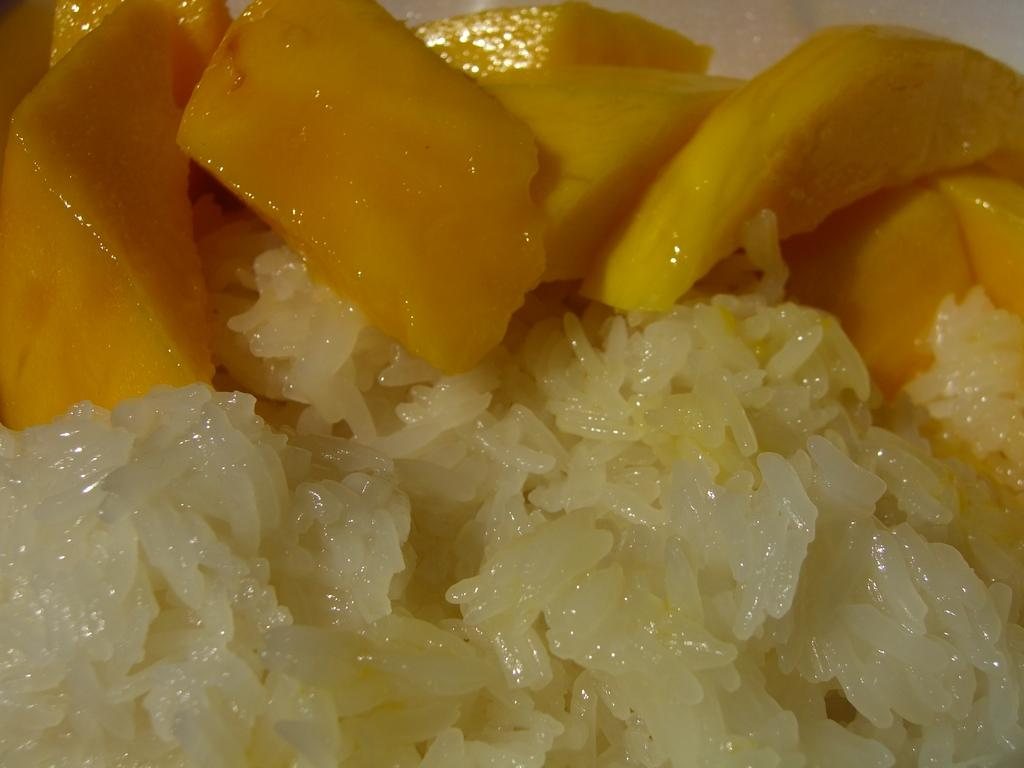What type of food can be seen in the image? There is food in the image, but the specific type cannot be determined from the provided facts. Can you identify any specific fruits in the image? Yes, there are fruits in the image. However, the specific types of fruits cannot be determined from the provided facts. What type of spring can be seen in the image? There is no spring present in the image. Can you describe the harbor in the image? There is no harbor present in the image. 